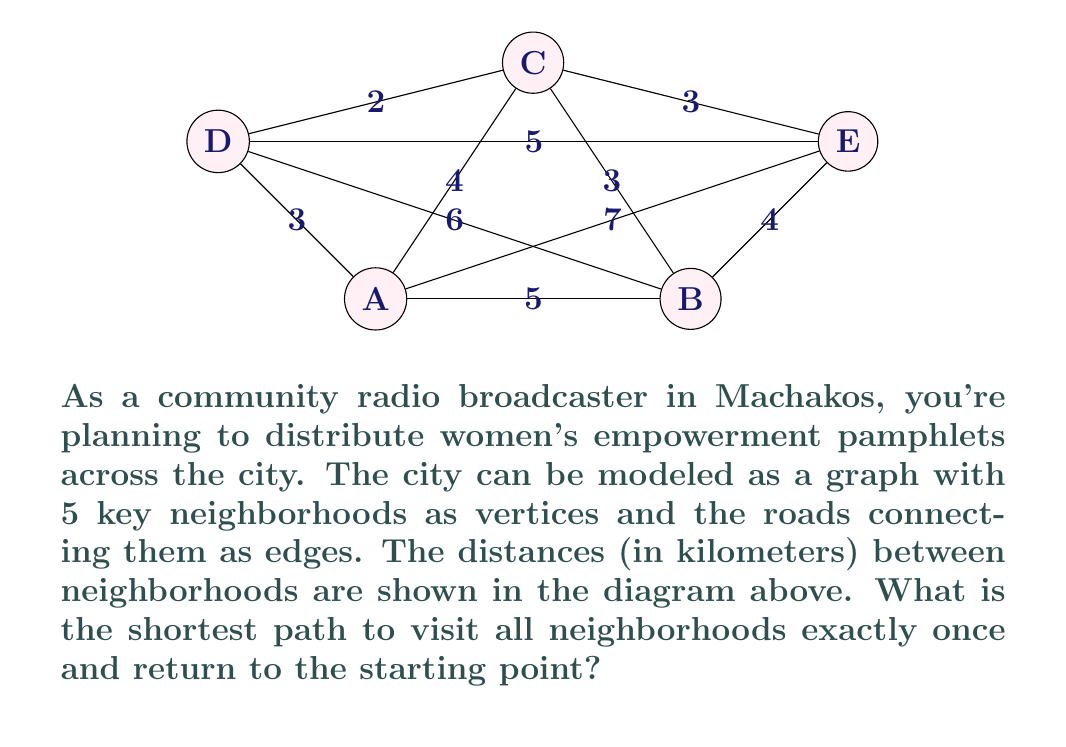What is the answer to this math problem? To solve this problem, we need to find the Hamiltonian cycle with the minimum total distance. This is known as the Traveling Salesman Problem (TSP).

Given the small number of vertices, we can use a brute-force approach:

1) List all possible Hamiltonian cycles:
   A-B-C-D-E-A
   A-B-C-E-D-A
   A-B-D-C-E-A
   A-B-D-E-C-A
   A-B-E-C-D-A
   A-B-E-D-C-A
   (and their reverses, which have the same total distance)

2) Calculate the total distance for each cycle:
   A-B-C-D-E-A: $5 + 3 + 2 + 5 + 7 = 22$ km
   A-B-C-E-D-A: $5 + 3 + 3 + 5 + 3 = 19$ km
   A-B-D-C-E-A: $5 + 6 + 2 + 3 + 7 = 23$ km
   A-B-D-E-C-A: $5 + 6 + 5 + 3 + 4 = 23$ km
   A-B-E-C-D-A: $5 + 4 + 3 + 2 + 3 = 17$ km
   A-B-E-D-C-A: $5 + 4 + 5 + 2 + 4 = 20$ km

3) The minimum distance is 17 km, corresponding to the path A-B-E-C-D-A.

This solution ensures that all neighborhoods are visited exactly once, and the broadcaster returns to the starting point (A) after distributing pamphlets in all areas.
Answer: A-B-E-C-D-A, 17 km 